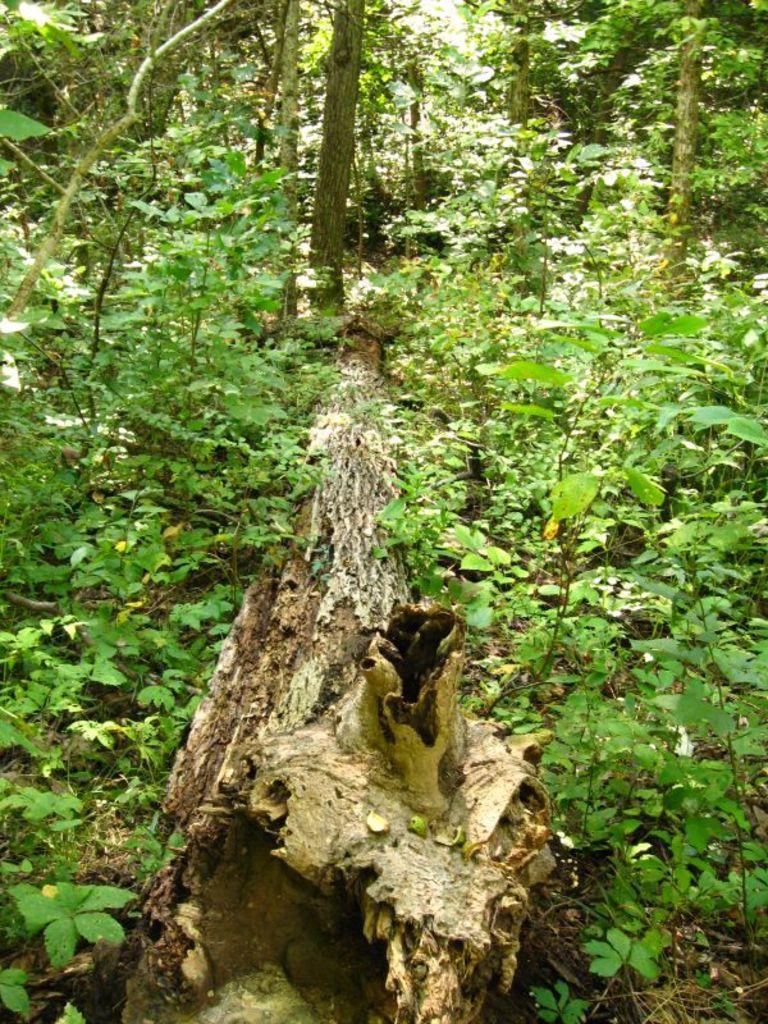Describe this image in one or two sentences. In this image I can see in the middle there is a log and there are trees in green color. 